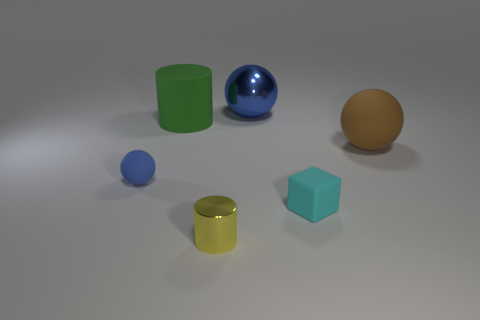What shape is the big object that is the same color as the small rubber ball?
Provide a short and direct response. Sphere. How many gray blocks are made of the same material as the small ball?
Offer a very short reply. 0. There is a small cylinder; how many small objects are behind it?
Provide a short and direct response. 2. What is the size of the yellow cylinder?
Give a very brief answer. Small. There is a metal cylinder that is the same size as the blue matte object; what color is it?
Give a very brief answer. Yellow. Is there a big cylinder of the same color as the cube?
Your answer should be very brief. No. What is the material of the brown sphere?
Provide a short and direct response. Rubber. How many big cylinders are there?
Your answer should be very brief. 1. Is the color of the small rubber thing on the right side of the blue rubber thing the same as the tiny rubber thing that is on the left side of the tiny yellow cylinder?
Your answer should be compact. No. There is a matte object that is the same color as the large shiny object; what is its size?
Make the answer very short. Small. 